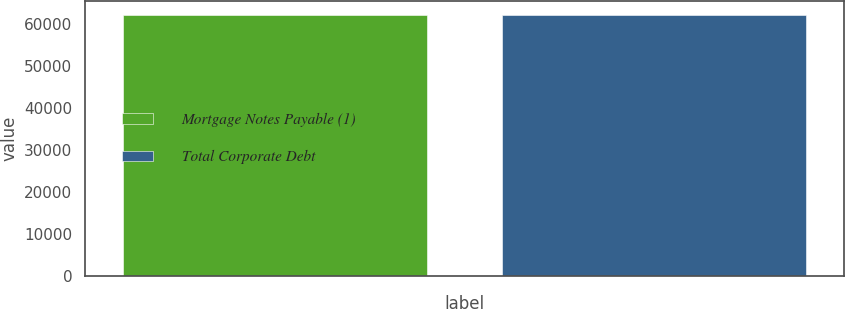Convert chart to OTSL. <chart><loc_0><loc_0><loc_500><loc_500><bar_chart><fcel>Mortgage Notes Payable (1)<fcel>Total Corporate Debt<nl><fcel>62224<fcel>62224.1<nl></chart> 